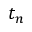Convert formula to latex. <formula><loc_0><loc_0><loc_500><loc_500>t _ { n }</formula> 